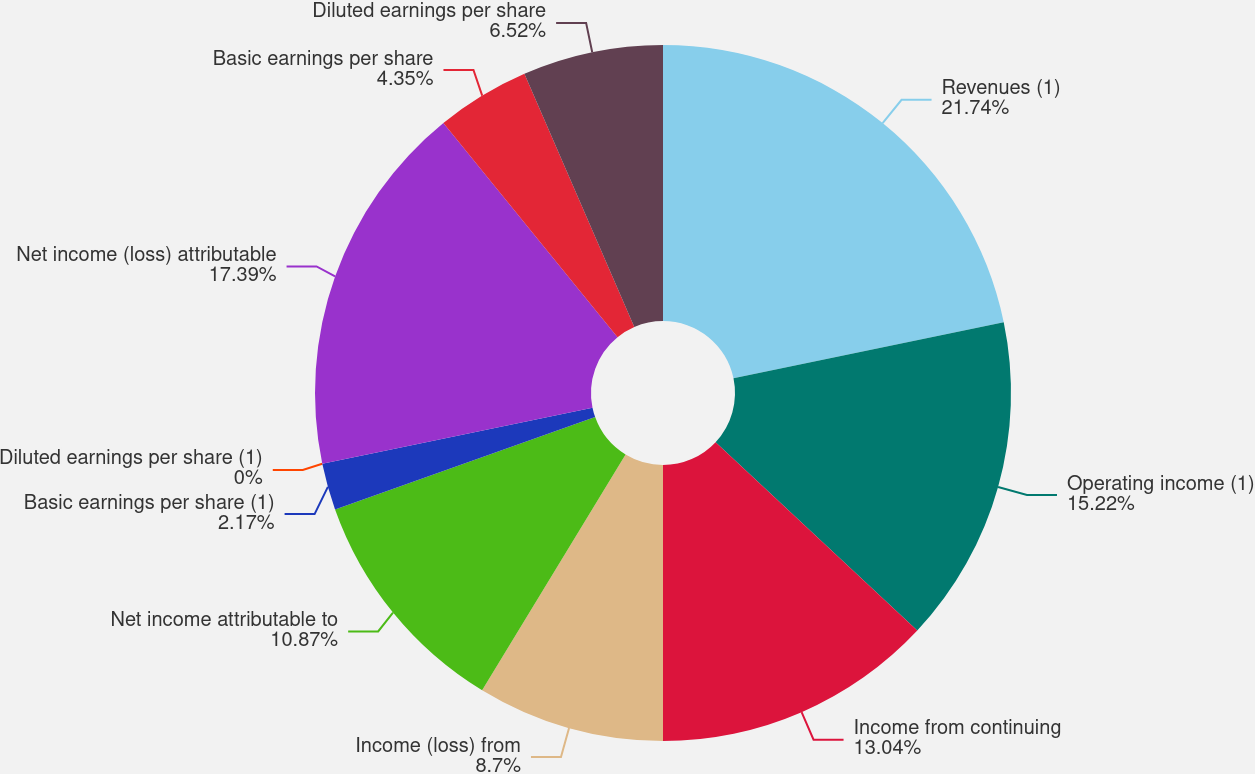<chart> <loc_0><loc_0><loc_500><loc_500><pie_chart><fcel>Revenues (1)<fcel>Operating income (1)<fcel>Income from continuing<fcel>Income (loss) from<fcel>Net income attributable to<fcel>Basic earnings per share (1)<fcel>Diluted earnings per share (1)<fcel>Net income (loss) attributable<fcel>Basic earnings per share<fcel>Diluted earnings per share<nl><fcel>21.74%<fcel>15.22%<fcel>13.04%<fcel>8.7%<fcel>10.87%<fcel>2.17%<fcel>0.0%<fcel>17.39%<fcel>4.35%<fcel>6.52%<nl></chart> 